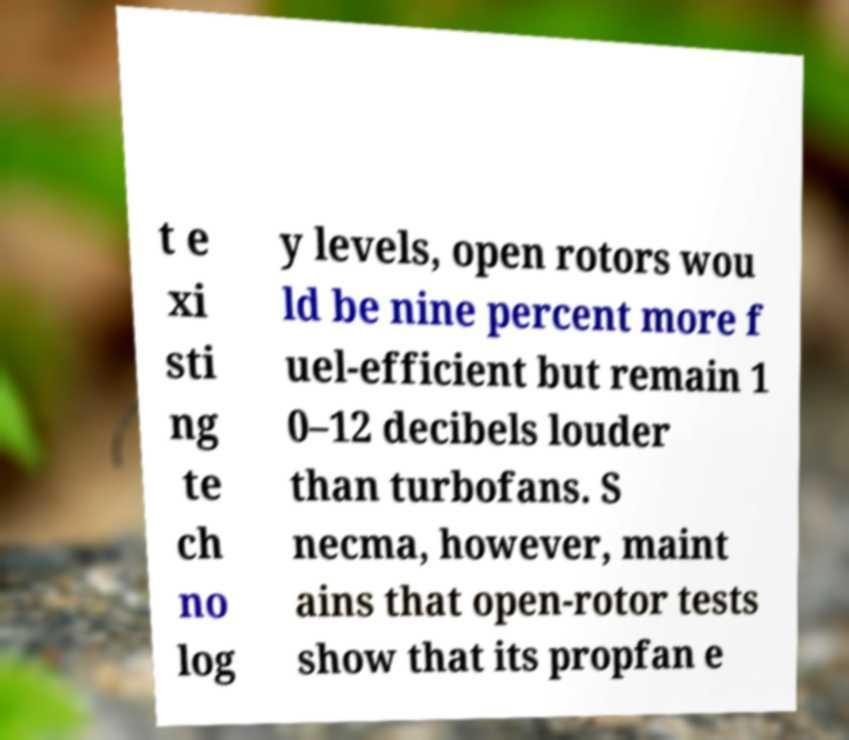I need the written content from this picture converted into text. Can you do that? t e xi sti ng te ch no log y levels, open rotors wou ld be nine percent more f uel-efficient but remain 1 0–12 decibels louder than turbofans. S necma, however, maint ains that open-rotor tests show that its propfan e 